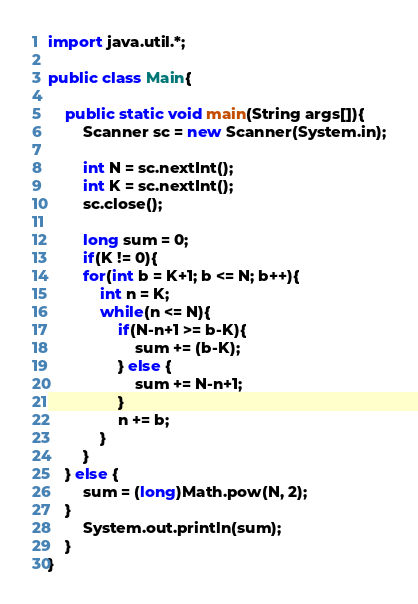<code> <loc_0><loc_0><loc_500><loc_500><_Java_>import java.util.*;

public class Main{
    
    public static void main(String args[]){
        Scanner sc = new Scanner(System.in);

        int N = sc.nextInt();
        int K = sc.nextInt();
        sc.close();

        long sum = 0;
        if(K != 0){
        for(int b = K+1; b <= N; b++){
            int n = K;
            while(n <= N){
                if(N-n+1 >= b-K){
                    sum += (b-K);
                } else {
                    sum += N-n+1;
                }
                n += b;
            }
        }
    } else {
        sum = (long)Math.pow(N, 2);
    }
        System.out.println(sum);
    }
}</code> 